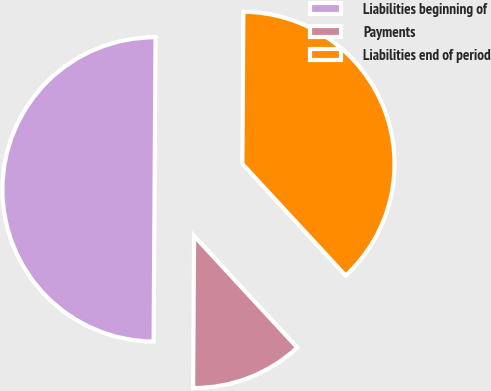Convert chart to OTSL. <chart><loc_0><loc_0><loc_500><loc_500><pie_chart><fcel>Liabilities beginning of<fcel>Payments<fcel>Liabilities end of period<nl><fcel>50.0%<fcel>11.97%<fcel>38.03%<nl></chart> 